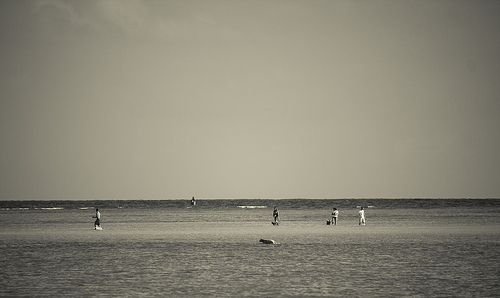Capture the serenity of the beach scene. The vast openness of the shoreline is met with gentle sea waves, while sparse figures dot the landscape, each engaged in their own tranquil activity. Describe the feelings evoked by this image. The solitude of the subjects amidst the grandeur of nature elicits a sense of peace, introspection, and a longing for simplicity in the viewer. 